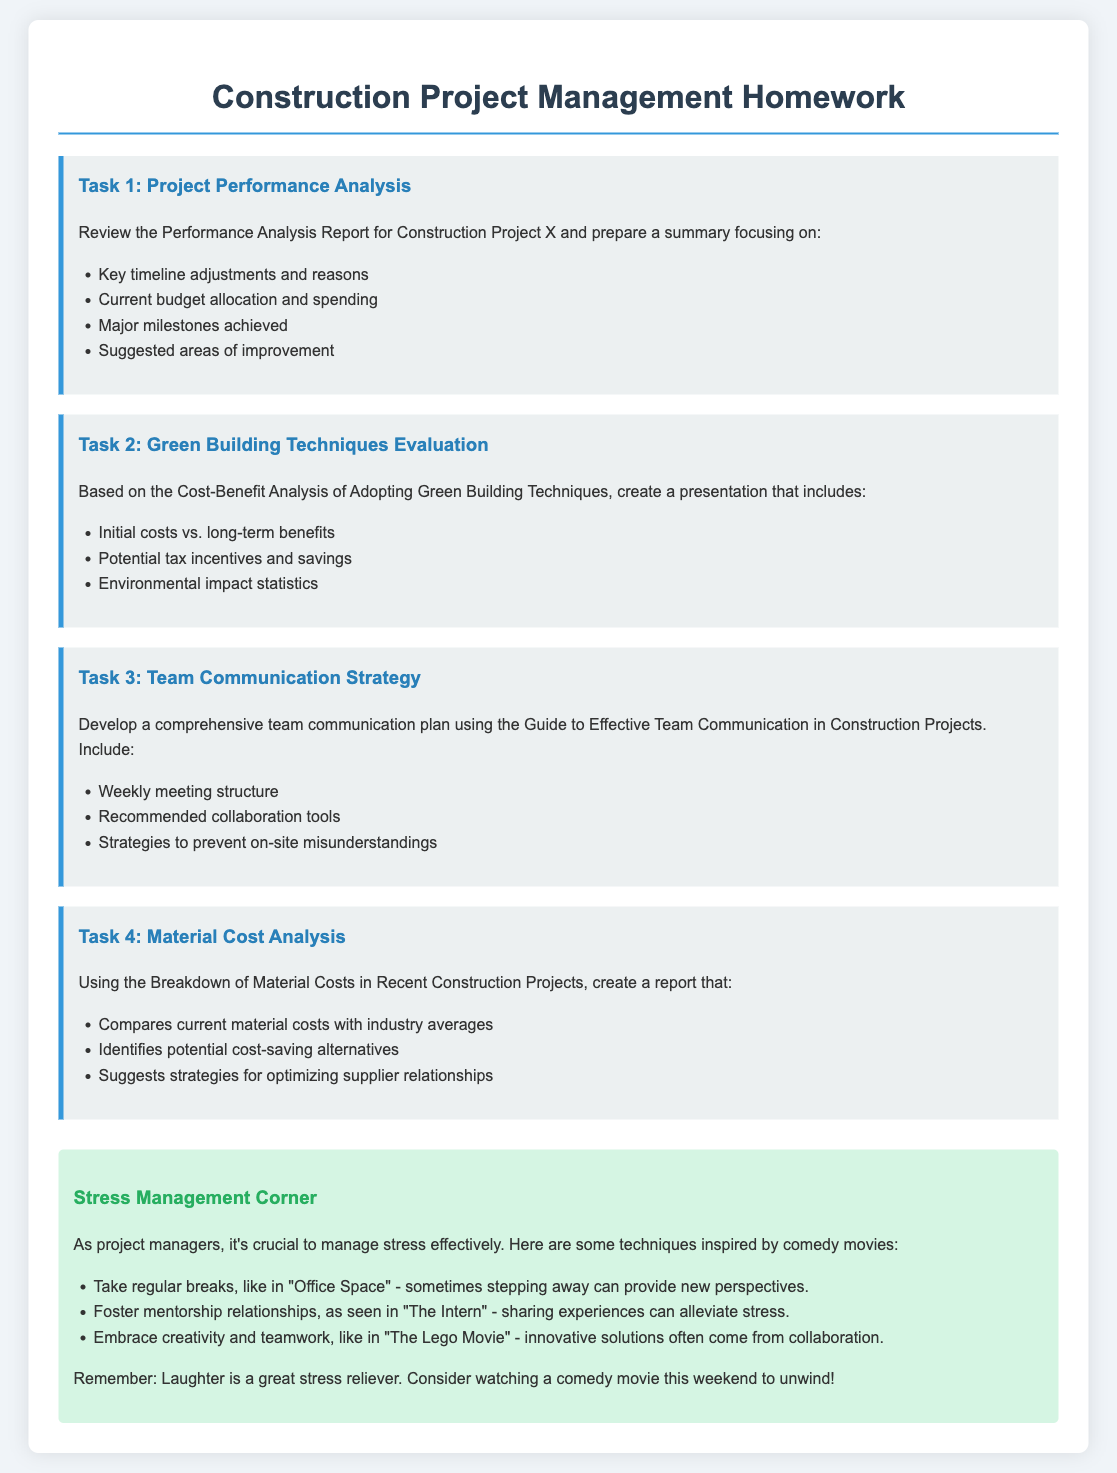What is the title of the homework document? The title of the document is specified at the beginning, indicating the focus on construction project management.
Answer: Construction Project Management Homework How many tasks are outlined in the homework? The document lists four main tasks related to project management, followed by a section on stress management.
Answer: Four What color is used for the headings in the tasks section? The document mentions the color used in the styling for task headings, specifically a shade of blue.
Answer: Blue What is the focus of Task 2 in the homework? Task 2 is focused on evaluating the financial implications and environmental impact of using certain building techniques.
Answer: Green Building Techniques Evaluation What technique inspired by a comedy movie is suggested for stress management? The document describes various techniques, one of which involves taking regular breaks as suggested in a specific comedy film.
Answer: Office Space List one collaboration tool recommended in the communication plan. The document does not specify exact tools, but indicates that a list of recommended collaboration tools should be included in the plan.
Answer: Recommended collaboration tools What is the suggested outcome of the Material Cost Analysis task? The document outlines the expectation to identify cost-saving alternatives and optimize supplier relationships.
Answer: Cost-saving alternatives How are stress management techniques categorized in the document? The techniques are inspired by popular culture, specifically comedy movies, which serve as examples for project managers.
Answer: Stress Management Corner 